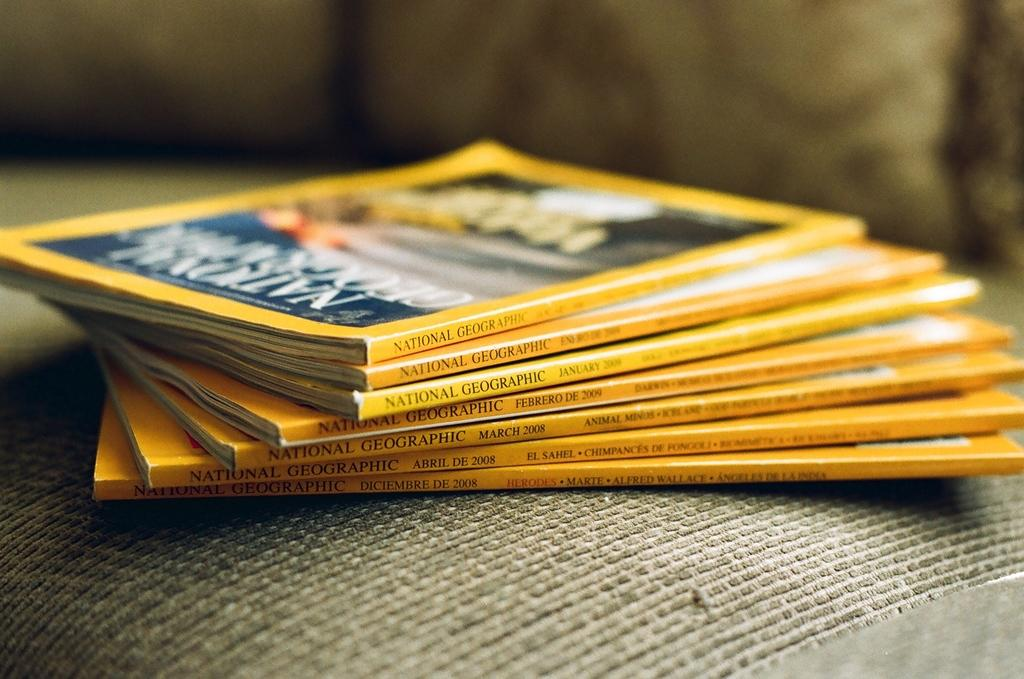<image>
Render a clear and concise summary of the photo. a stack of National Geographic magazines. 